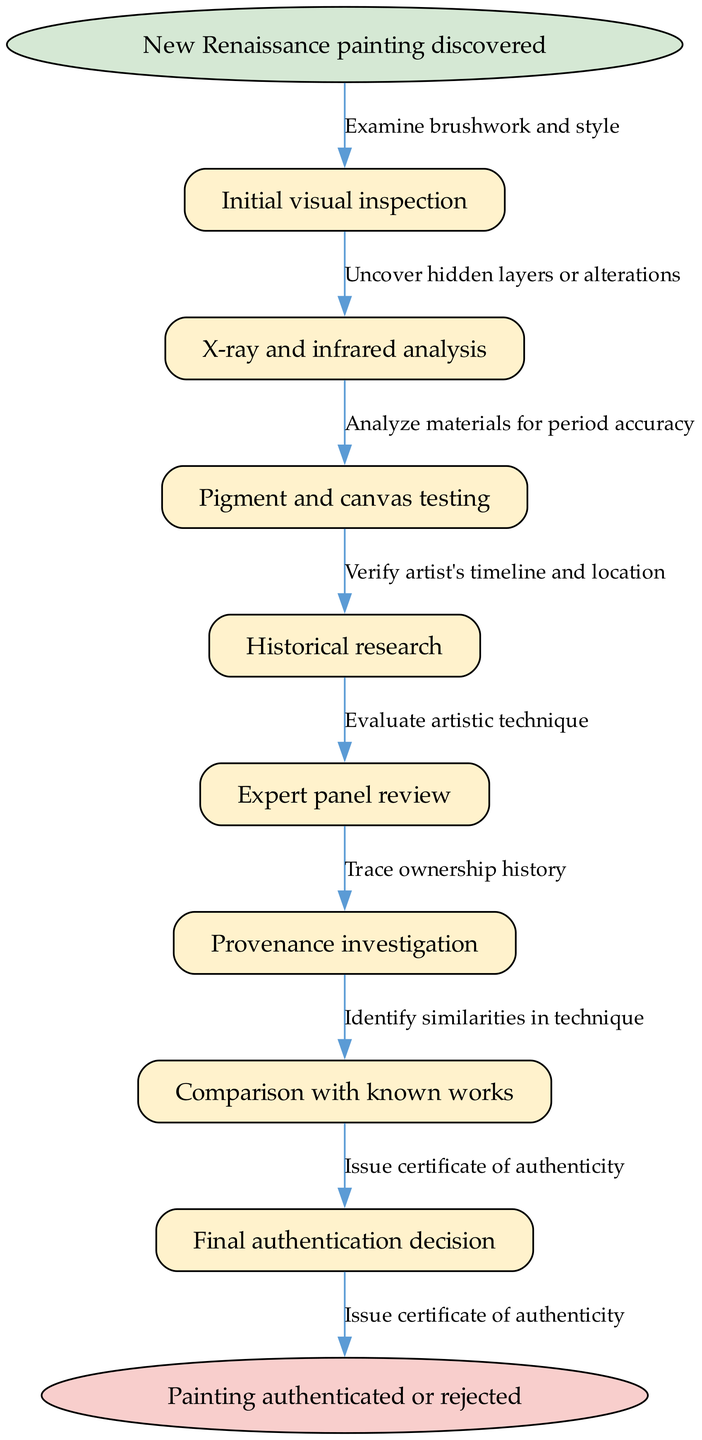What is the starting point of the authentication process? The starting point of the authentication process is listed clearly in the diagram as "New Renaissance painting discovered." This serves as the initial node that indicates where the procedure begins.
Answer: New Renaissance painting discovered How many nodes are in the flowchart? The flowchart contains a total of 8 nodes, including the start node, the end node, and the six nodes representing different steps in the authentication process.
Answer: 8 What is the last step mentioned before the final authentication decision? The last step before the final authentication decision in the diagram is "Comparison with known works." This step indicates that prior to concluding the authentication process, similar known works are compared.
Answer: Comparison with known works What type of analysis follows the initial visual inspection? The analysis that follows the initial visual inspection is "X-ray and infrared analysis." This step is crucial as it provides deeper insights into the painting's layers, which may not be visible to the naked eye.
Answer: X-ray and infrared analysis What do you need to evaluate next after pigment and canvas testing? After pigment and canvas testing, the next step is to perform "Historical research." This connects the authenticity of the painting to its historical context, verifying its significance based on period details.
Answer: Historical research Which edge connects “Expert panel review” to the final decision? The edge that connects "Expert panel review" to the final decision is "Issue certificate of authenticity." This action represents the conclusion of the authentication process once everything has been thoroughly reviewed.
Answer: Issue certificate of authenticity How many testing steps are there in total? There are a total of 3 testing steps in the diagram: "Pigment and canvas testing," "X-ray and infrared analysis," and "Initial visual inspection." Each of these steps contributes to the evaluation of the painting's authenticity.
Answer: 3 What is the outcome of the process? The outcome of the process is either "Painting authenticated or rejected." This result is determined after the cumulative evaluations and analyses performed throughout the procedure.
Answer: Painting authenticated or rejected What might be uncovered through X-ray and infrared analysis? X-ray and infrared analysis may "Uncover hidden layers or alterations." This step helps to expose any modifications made to the painting, which is essential for accurate authentication.
Answer: Uncover hidden layers or alterations 